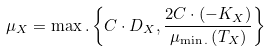<formula> <loc_0><loc_0><loc_500><loc_500>\mu _ { X } = \max . \left \{ C \cdot D _ { X } , \frac { 2 C \cdot \left ( - K _ { X } \right ) } { \mu _ { \min . } \left ( T _ { X } \right ) } \right \}</formula> 